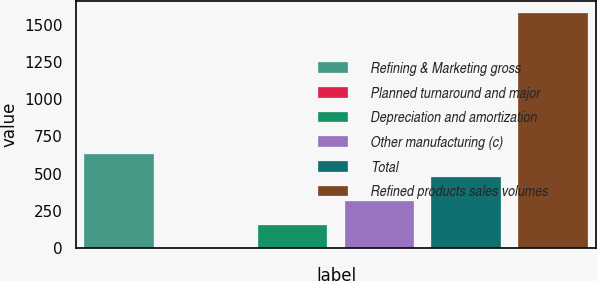<chart> <loc_0><loc_0><loc_500><loc_500><bar_chart><fcel>Refining & Marketing gross<fcel>Planned turnaround and major<fcel>Depreciation and amortization<fcel>Other manufacturing (c)<fcel>Total<fcel>Refined products sales volumes<nl><fcel>632.86<fcel>0.78<fcel>158.8<fcel>316.82<fcel>474.84<fcel>1581<nl></chart> 